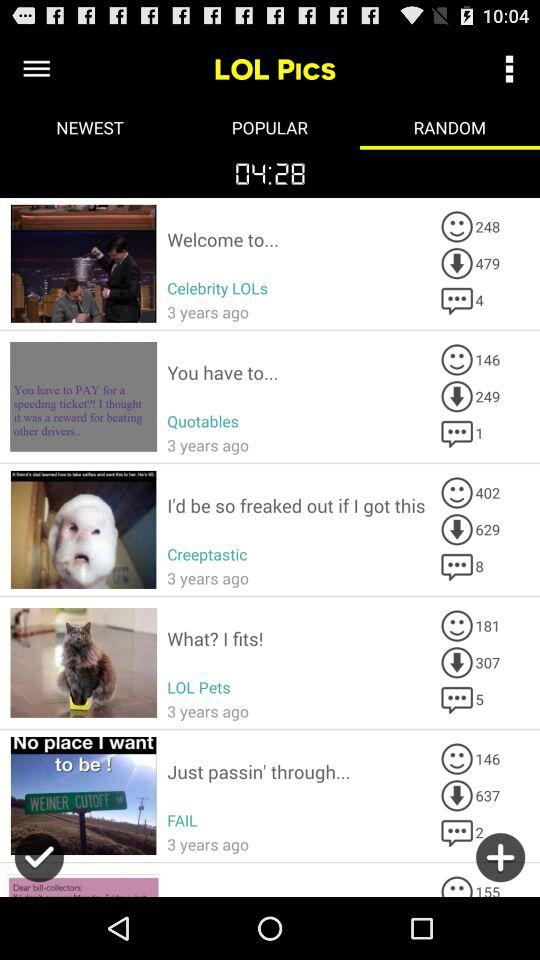Which pic has 637 downloads in "LOL Pics"? The pic "Just passin' through..." has 637 downloads in "LOL Pics". 